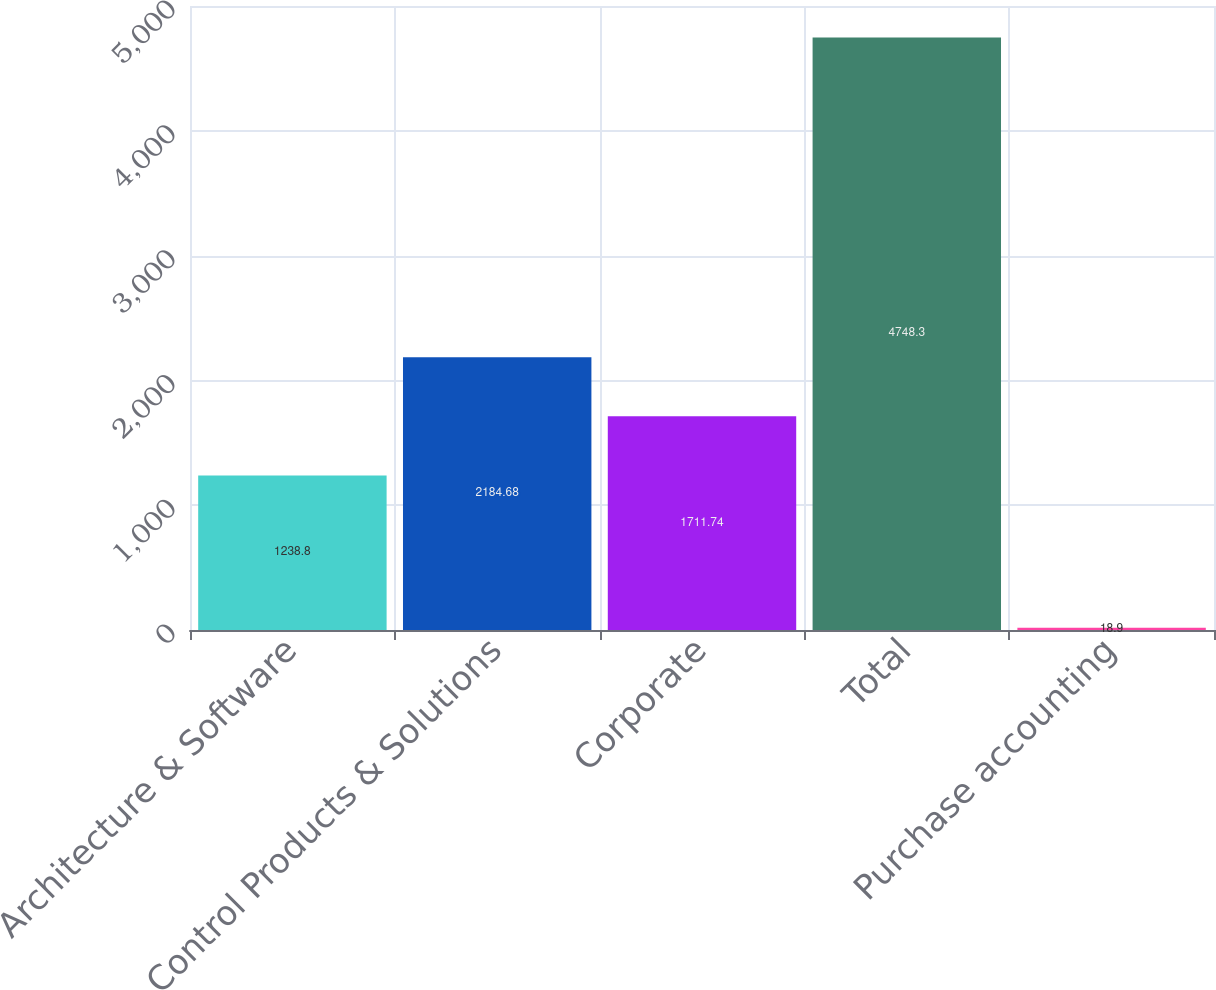Convert chart. <chart><loc_0><loc_0><loc_500><loc_500><bar_chart><fcel>Architecture & Software<fcel>Control Products & Solutions<fcel>Corporate<fcel>Total<fcel>Purchase accounting<nl><fcel>1238.8<fcel>2184.68<fcel>1711.74<fcel>4748.3<fcel>18.9<nl></chart> 